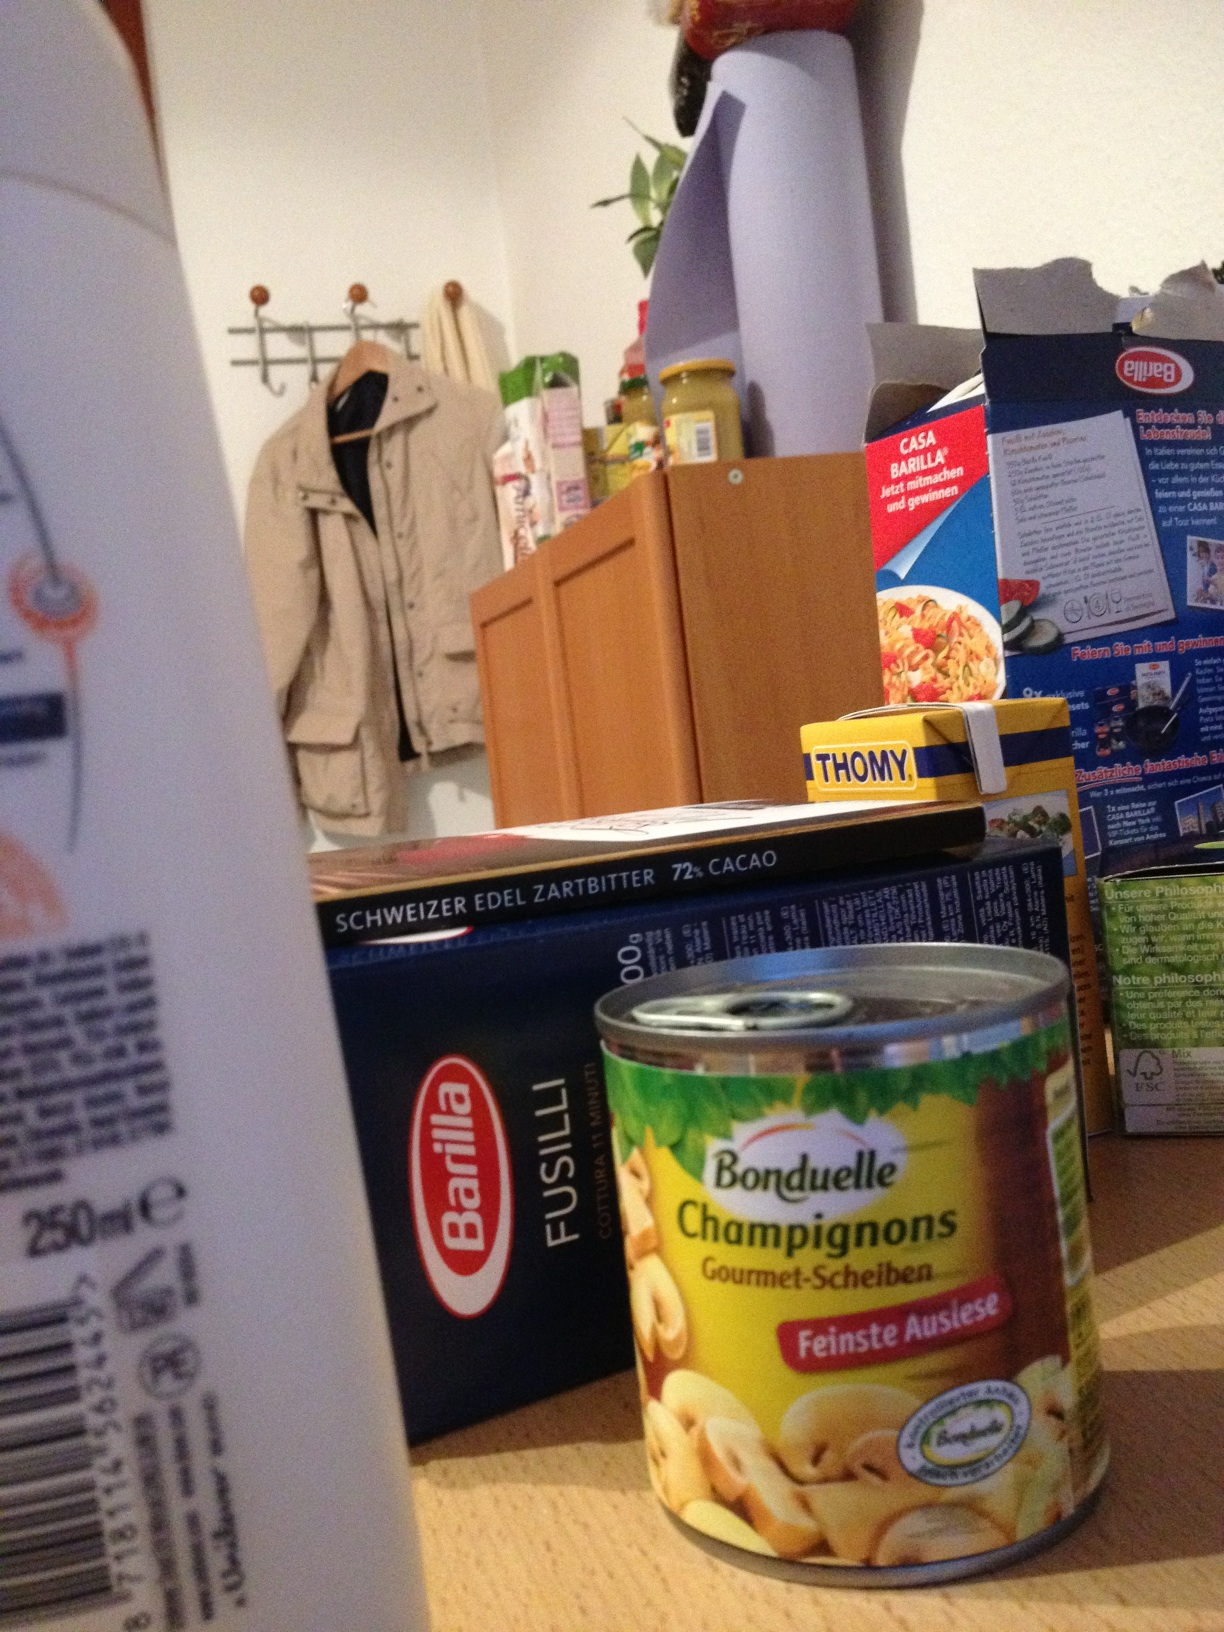What type of chocolate is shown in the image? The box in the image is labeled as Swiss Premium Edel Zartbitter, which translates to 'fine dark' chocolate. It's a high-quality Swiss dark chocolate, known for its rich flavor and smooth texture. How is dark chocolate beneficial? Dark chocolate is rich in antioxidants, specifically flavonoids, which are believed to help improve heart health by lowering blood pressure and improving blood flow. It also contains minerals like iron, magnesium, and zinc, and can be a mood enhancer. 